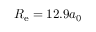<formula> <loc_0><loc_0><loc_500><loc_500>R _ { e } = 1 2 . 9 a _ { 0 }</formula> 